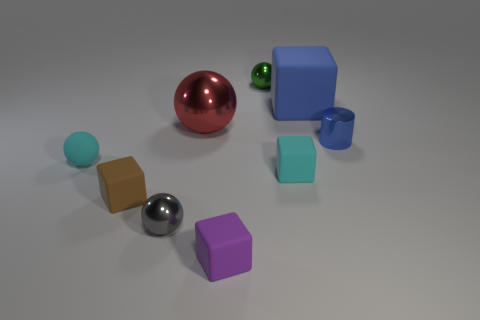What material is the small object that is the same color as the big matte cube?
Your response must be concise. Metal. Does the small cube that is behind the tiny brown matte block have the same color as the tiny matte object that is behind the cyan block?
Make the answer very short. Yes. How many other objects are the same color as the matte sphere?
Give a very brief answer. 1. Is the number of tiny cyan rubber things greater than the number of small gray balls?
Provide a succinct answer. Yes. What is the small gray ball made of?
Give a very brief answer. Metal. Does the blue object that is on the left side of the blue metallic cylinder have the same size as the large red thing?
Your response must be concise. Yes. There is a metal ball behind the red metal ball; how big is it?
Your answer should be compact. Small. How many small red spheres are there?
Provide a short and direct response. 0. Is the large rubber object the same color as the cylinder?
Make the answer very short. Yes. The small shiny object that is on the left side of the cyan block and in front of the tiny green metal sphere is what color?
Provide a short and direct response. Gray. 